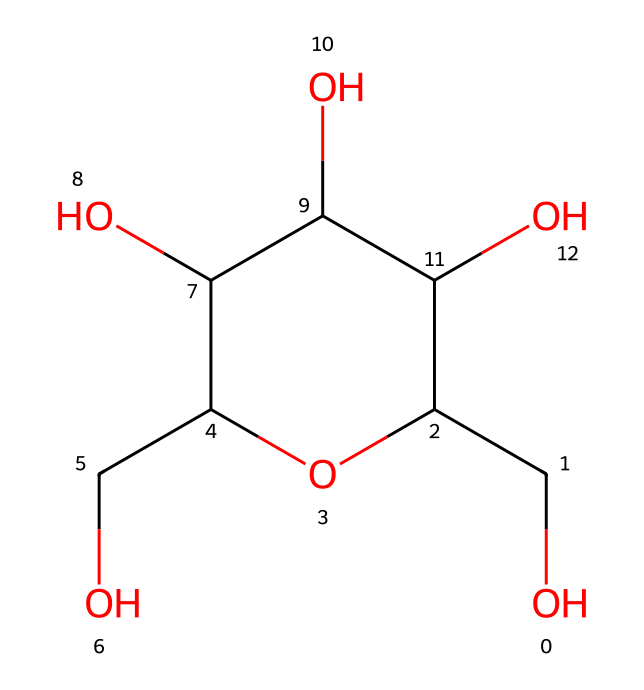What is the main functional group present in this chemical? The structure contains multiple hydroxyl (-OH) groups, which classify it as an alcohol.
Answer: hydroxyl How many carbon atoms are in this chemical structure? Counting the carbon atoms in the SMILES string, we find five carbon atoms in total.
Answer: five What type of bond connects the carbon atoms in this molecule? The carbon atoms are primarily connected by single covalent bonds, typical in alcohols, as indicated by the absence of double bonds in the structure.
Answer: single What is the general name for the type of fiber this chemical represents? This chemical is a derivative of cellulose, commonly known as rayon, specifically bamboo rayon.
Answer: rayon How many oxygen atoms are present in this chemical structure? By counting the oxygens in the SMILES, there are three oxygen atoms present in the structure.
Answer: three What is the characteristic property of bamboo rayon that makes it eco-friendly? Bamboo rayon is biodegradable and produced from a renewable resource, making it a sustainable option for eco-friendly apparel.
Answer: biodegradable What is the significance of the hydroxyl groups in bamboo rayon? The hydroxyl groups contribute to the moisture-wicking properties of bamboo rayon, enhancing its comfort and performance in fitness apparel.
Answer: moisture-wicking 